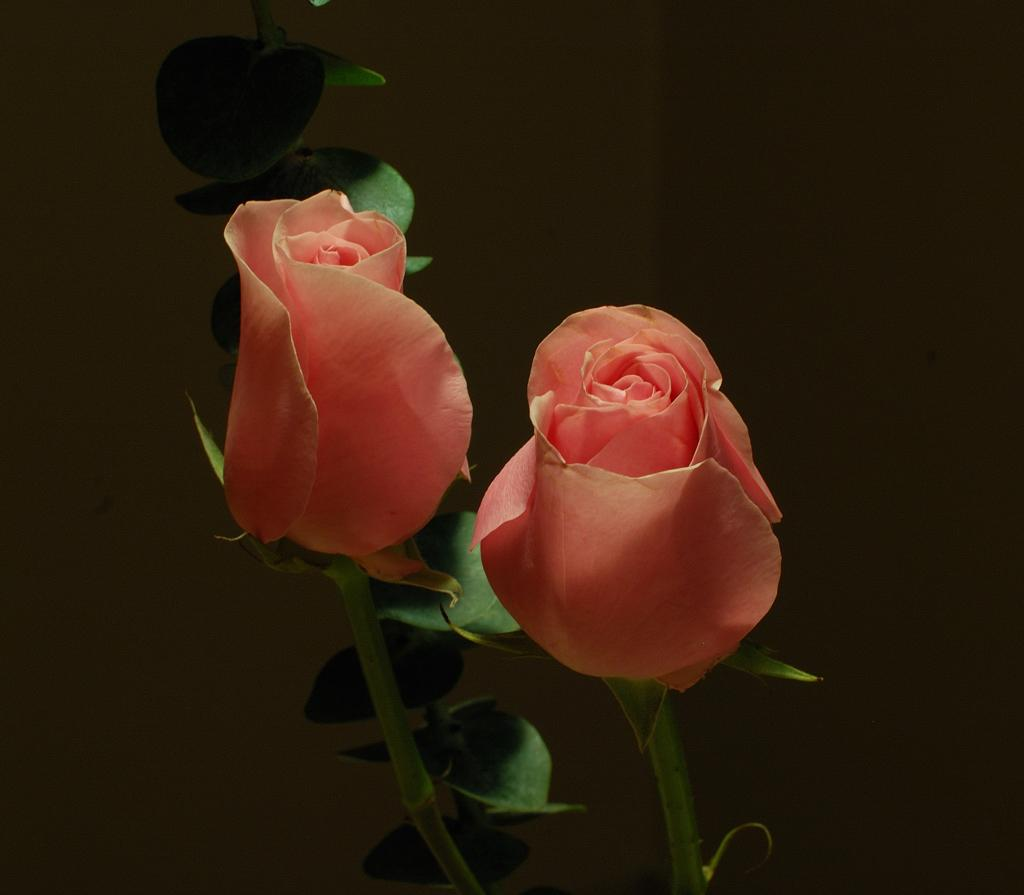What type of flowers are in the image? There are two rose flowers in the image. What color are the rose flowers? The rose flowers are pink in color. What else can be seen in the image besides the flowers? There are stems and leaves in the image. How would you describe the background of the image? The background of the image is dark. What type of brick is used to build the fence in the image? There is no fence or brick present in the image; it features two pink rose flowers with stems and leaves. What is the weather like in the image? The provided facts do not mention any information about the weather, so it cannot be determined from the image. 